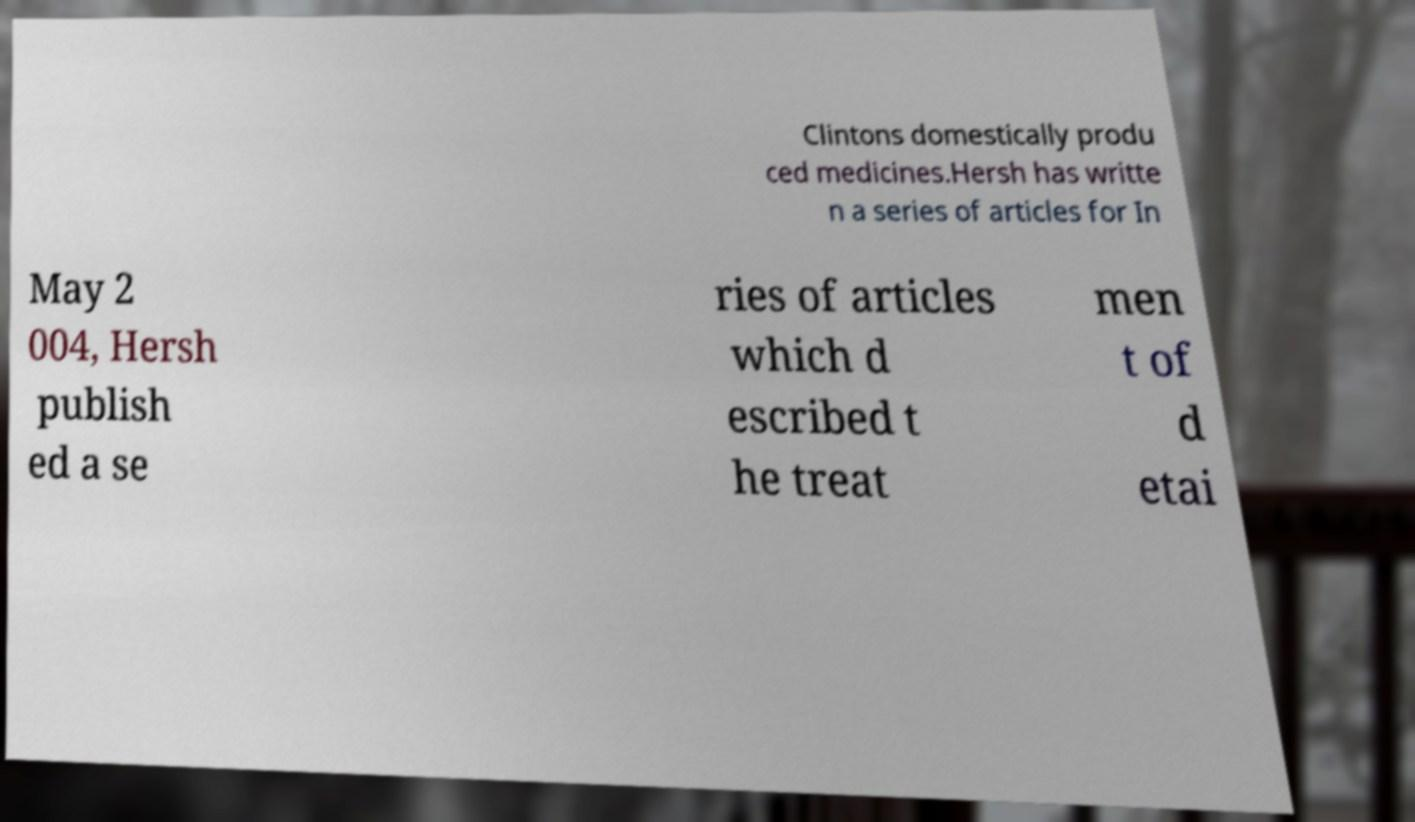Could you extract and type out the text from this image? Clintons domestically produ ced medicines.Hersh has writte n a series of articles for In May 2 004, Hersh publish ed a se ries of articles which d escribed t he treat men t of d etai 